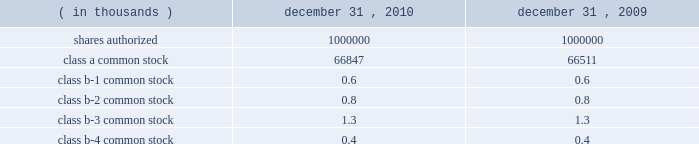Interest rate derivatives .
In connection with the issuance of floating rate debt in august and october 2008 , the company entered into three interest rate swap contracts , designated as cash flow hedges , for purposes of hedging against a change in interest payments due to fluctuations in the underlying benchmark rate .
In december 2010 , the company approved a plan to refinance the term loan in january 2011 resulting in an $ 8.6 million loss on derivative instruments as a result of ineffectiveness on the associated interest rate swap contract .
To mitigate counterparty credit risk , the interest rate swap contracts required collateralization by both counterparties for the swaps 2019 aggregate net fair value during their respective terms .
Collateral was maintained in the form of cash and adjusted on a daily basis .
In february 2010 , the company entered into a forward starting interest rate swap contract , designated as a cash flow hedge , for purposes of hedging against a change in interest payments due to fluctuations in the underlying benchmark rate between the date of the swap and the forecasted issuance of fixed rate debt in march 2010 .
The swap was highly effective .
Foreign currency derivatives .
In connection with its purchase of bm&fbovespa stock in february 2008 , cme group purchased a put option to hedge against changes in the fair value of bm&fbovespa stock resulting from foreign currency rate fluctuations between the u.s .
Dollar and the brazilian real ( brl ) beyond the option 2019s exercise price .
Lehman brothers special financing inc .
( lbsf ) was the sole counterparty to this option contract .
On september 15 , 2008 , lehman brothers holdings inc .
( lehman ) filed for protection under chapter 11 of the united states bankruptcy code .
The bankruptcy filing of lehman was an event of default that gave the company the right to immediately terminate the put option agreement with lbsf .
In march 2010 , the company recognized a $ 6.0 million gain on derivative instruments as a result of a settlement from the lehman bankruptcy proceedings .
21 .
Capital stock shares outstanding .
The table presents information regarding capital stock: .
Cme group has no shares of preferred stock issued and outstanding .
Associated trading rights .
Members of cme , cbot , nymex and comex own or lease trading rights which entitle them to access the trading floors , discounts on trading fees and the right to vote on certain exchange matters as provided for by the rules of the particular exchange and cme group 2019s or the subsidiaries 2019 organizational documents .
Each class of cme group class b common stock is associated with a membership in a specific division for trading at cme .
A cme trading right is a separate asset that is not part of or evidenced by the associated share of class b common stock of cme group .
The class b common stock of cme group is intended only to ensure that the class b shareholders of cme group retain rights with respect to representation on the board of directors and approval rights with respect to the core rights described below .
Trading rights at cbot are evidenced by class b memberships in cbot , at nymex by class a memberships in nymex and at comex by comex division memberships in comex .
Members of the cbot , nymex and comex exchanges do not have any rights to elect members of the board of directors and are not entitled to receive dividends or other distributions on their memberships .
The company is , however , required to have at least 10 cbot directors ( as defined by its bylaws ) until its 2012 annual meeting. .
In 2010 what was the percent of the shares authorized that was class-a common stock? 
Computations: (66847 / 1000000)
Answer: 0.06685. Interest rate derivatives .
In connection with the issuance of floating rate debt in august and october 2008 , the company entered into three interest rate swap contracts , designated as cash flow hedges , for purposes of hedging against a change in interest payments due to fluctuations in the underlying benchmark rate .
In december 2010 , the company approved a plan to refinance the term loan in january 2011 resulting in an $ 8.6 million loss on derivative instruments as a result of ineffectiveness on the associated interest rate swap contract .
To mitigate counterparty credit risk , the interest rate swap contracts required collateralization by both counterparties for the swaps 2019 aggregate net fair value during their respective terms .
Collateral was maintained in the form of cash and adjusted on a daily basis .
In february 2010 , the company entered into a forward starting interest rate swap contract , designated as a cash flow hedge , for purposes of hedging against a change in interest payments due to fluctuations in the underlying benchmark rate between the date of the swap and the forecasted issuance of fixed rate debt in march 2010 .
The swap was highly effective .
Foreign currency derivatives .
In connection with its purchase of bm&fbovespa stock in february 2008 , cme group purchased a put option to hedge against changes in the fair value of bm&fbovespa stock resulting from foreign currency rate fluctuations between the u.s .
Dollar and the brazilian real ( brl ) beyond the option 2019s exercise price .
Lehman brothers special financing inc .
( lbsf ) was the sole counterparty to this option contract .
On september 15 , 2008 , lehman brothers holdings inc .
( lehman ) filed for protection under chapter 11 of the united states bankruptcy code .
The bankruptcy filing of lehman was an event of default that gave the company the right to immediately terminate the put option agreement with lbsf .
In march 2010 , the company recognized a $ 6.0 million gain on derivative instruments as a result of a settlement from the lehman bankruptcy proceedings .
21 .
Capital stock shares outstanding .
The table presents information regarding capital stock: .
Cme group has no shares of preferred stock issued and outstanding .
Associated trading rights .
Members of cme , cbot , nymex and comex own or lease trading rights which entitle them to access the trading floors , discounts on trading fees and the right to vote on certain exchange matters as provided for by the rules of the particular exchange and cme group 2019s or the subsidiaries 2019 organizational documents .
Each class of cme group class b common stock is associated with a membership in a specific division for trading at cme .
A cme trading right is a separate asset that is not part of or evidenced by the associated share of class b common stock of cme group .
The class b common stock of cme group is intended only to ensure that the class b shareholders of cme group retain rights with respect to representation on the board of directors and approval rights with respect to the core rights described below .
Trading rights at cbot are evidenced by class b memberships in cbot , at nymex by class a memberships in nymex and at comex by comex division memberships in comex .
Members of the cbot , nymex and comex exchanges do not have any rights to elect members of the board of directors and are not entitled to receive dividends or other distributions on their memberships .
The company is , however , required to have at least 10 cbot directors ( as defined by its bylaws ) until its 2012 annual meeting. .
What is the estimated percentual increase observed in the class a common stock during the years 2009 and 2010? 
Rationale: its the ratio between those two class a common stocks values during 2009 and 2010 .
Computations: ((66847 / 66511) - 1)
Answer: 0.00505. 